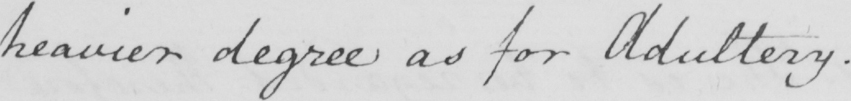Can you tell me what this handwritten text says? heavier degree as for Adultery . 